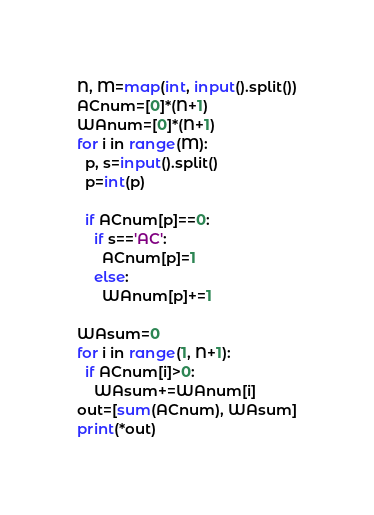Convert code to text. <code><loc_0><loc_0><loc_500><loc_500><_Python_>N, M=map(int, input().split())
ACnum=[0]*(N+1)
WAnum=[0]*(N+1)
for i in range(M):
  p, s=input().split()
  p=int(p)
  
  if ACnum[p]==0:
    if s=='AC':
      ACnum[p]=1
    else:
      WAnum[p]+=1

WAsum=0
for i in range(1, N+1):
  if ACnum[i]>0:
    WAsum+=WAnum[i]
out=[sum(ACnum), WAsum]
print(*out)</code> 